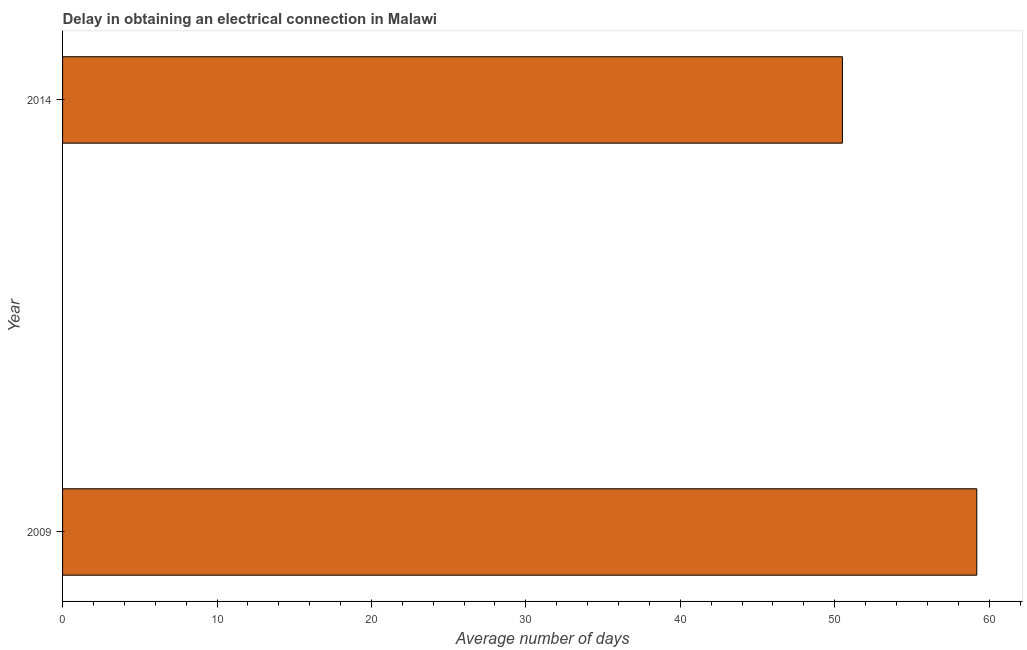Does the graph contain any zero values?
Give a very brief answer. No. Does the graph contain grids?
Ensure brevity in your answer.  No. What is the title of the graph?
Keep it short and to the point. Delay in obtaining an electrical connection in Malawi. What is the label or title of the X-axis?
Make the answer very short. Average number of days. What is the dalay in electrical connection in 2009?
Provide a short and direct response. 59.2. Across all years, what is the maximum dalay in electrical connection?
Make the answer very short. 59.2. Across all years, what is the minimum dalay in electrical connection?
Your answer should be compact. 50.5. In which year was the dalay in electrical connection minimum?
Your answer should be compact. 2014. What is the sum of the dalay in electrical connection?
Your answer should be very brief. 109.7. What is the average dalay in electrical connection per year?
Make the answer very short. 54.85. What is the median dalay in electrical connection?
Provide a short and direct response. 54.85. In how many years, is the dalay in electrical connection greater than 50 days?
Offer a terse response. 2. What is the ratio of the dalay in electrical connection in 2009 to that in 2014?
Give a very brief answer. 1.17. In how many years, is the dalay in electrical connection greater than the average dalay in electrical connection taken over all years?
Ensure brevity in your answer.  1. How many bars are there?
Ensure brevity in your answer.  2. How many years are there in the graph?
Your response must be concise. 2. What is the difference between two consecutive major ticks on the X-axis?
Ensure brevity in your answer.  10. What is the Average number of days of 2009?
Provide a short and direct response. 59.2. What is the Average number of days in 2014?
Your answer should be very brief. 50.5. What is the difference between the Average number of days in 2009 and 2014?
Keep it short and to the point. 8.7. What is the ratio of the Average number of days in 2009 to that in 2014?
Ensure brevity in your answer.  1.17. 